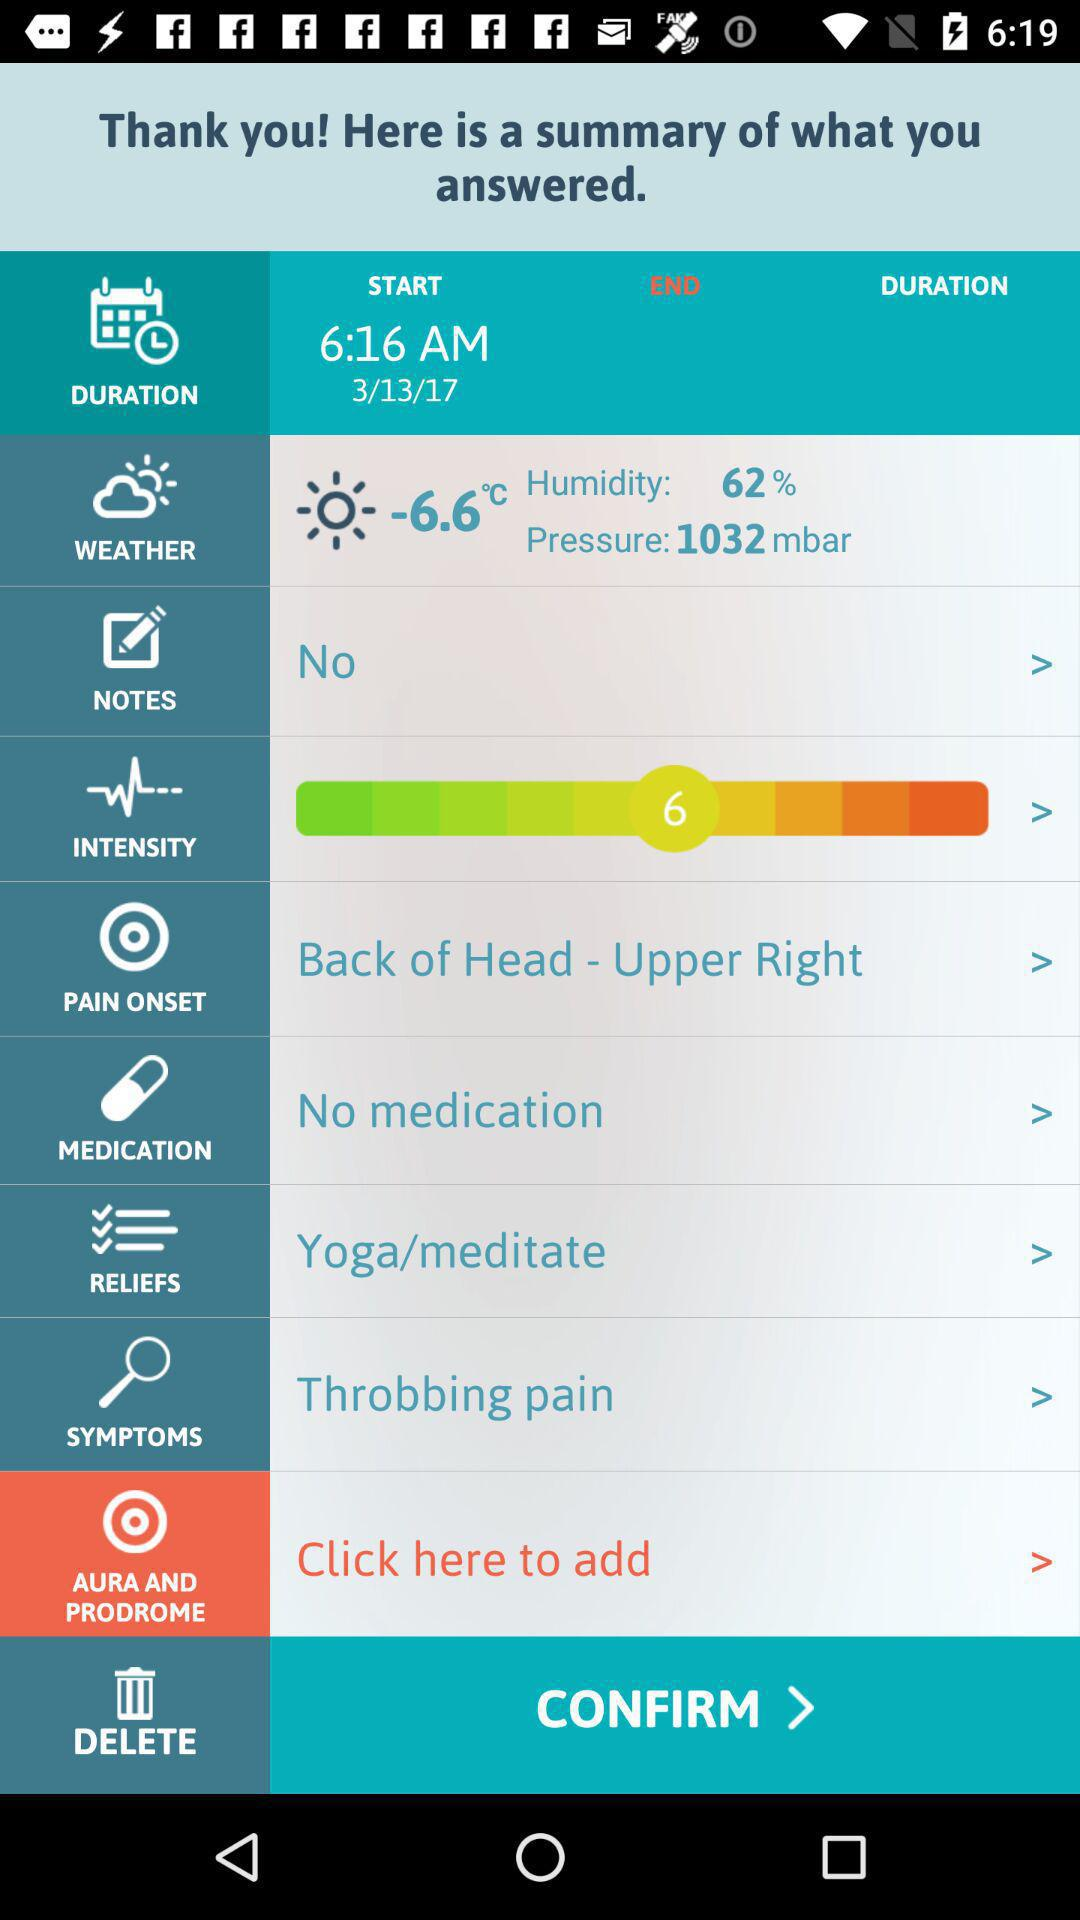What is the start time? The start time is 6:16 AM. 